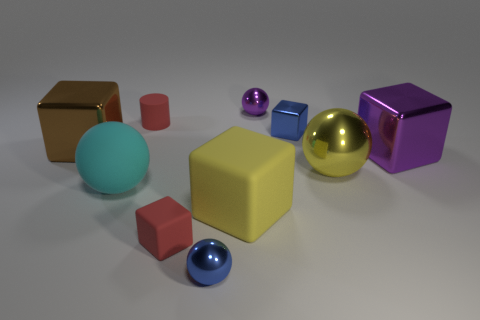What is the color of the metal cube to the left of the big yellow rubber thing?
Make the answer very short. Brown. Is the color of the large sphere that is on the right side of the red rubber cylinder the same as the large rubber cube?
Your answer should be very brief. Yes. What material is the purple object that is the same shape as the brown shiny thing?
Your response must be concise. Metal. What number of cyan matte objects have the same size as the brown thing?
Provide a succinct answer. 1. The large purple thing is what shape?
Offer a very short reply. Cube. What is the size of the sphere that is both on the right side of the red matte cube and in front of the large yellow shiny thing?
Keep it short and to the point. Small. There is a yellow object that is right of the large yellow cube; what is it made of?
Offer a very short reply. Metal. Does the small metal block have the same color as the small metal thing that is in front of the large yellow rubber object?
Your answer should be very brief. Yes. What number of objects are large cyan objects that are to the left of the large purple block or small shiny things in front of the cylinder?
Give a very brief answer. 3. There is a object that is left of the blue metal ball and behind the brown metallic object; what color is it?
Provide a short and direct response. Red. 